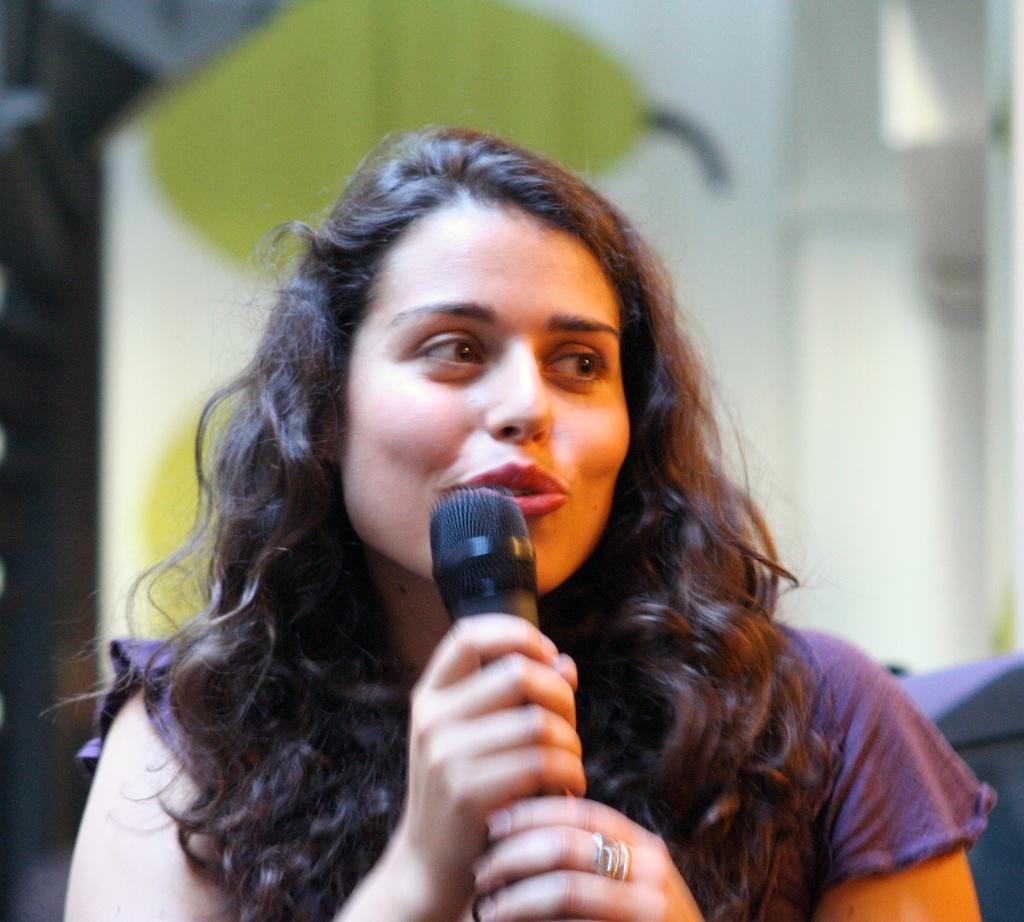How would you summarize this image in a sentence or two? Here we can see a woman speaking something in the microphone present in her hand 